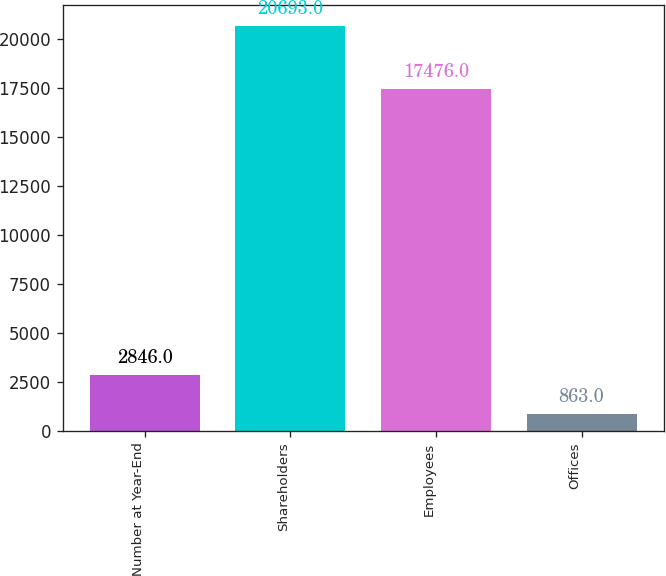Convert chart to OTSL. <chart><loc_0><loc_0><loc_500><loc_500><bar_chart><fcel>Number at Year-End<fcel>Shareholders<fcel>Employees<fcel>Offices<nl><fcel>2846<fcel>20693<fcel>17476<fcel>863<nl></chart> 